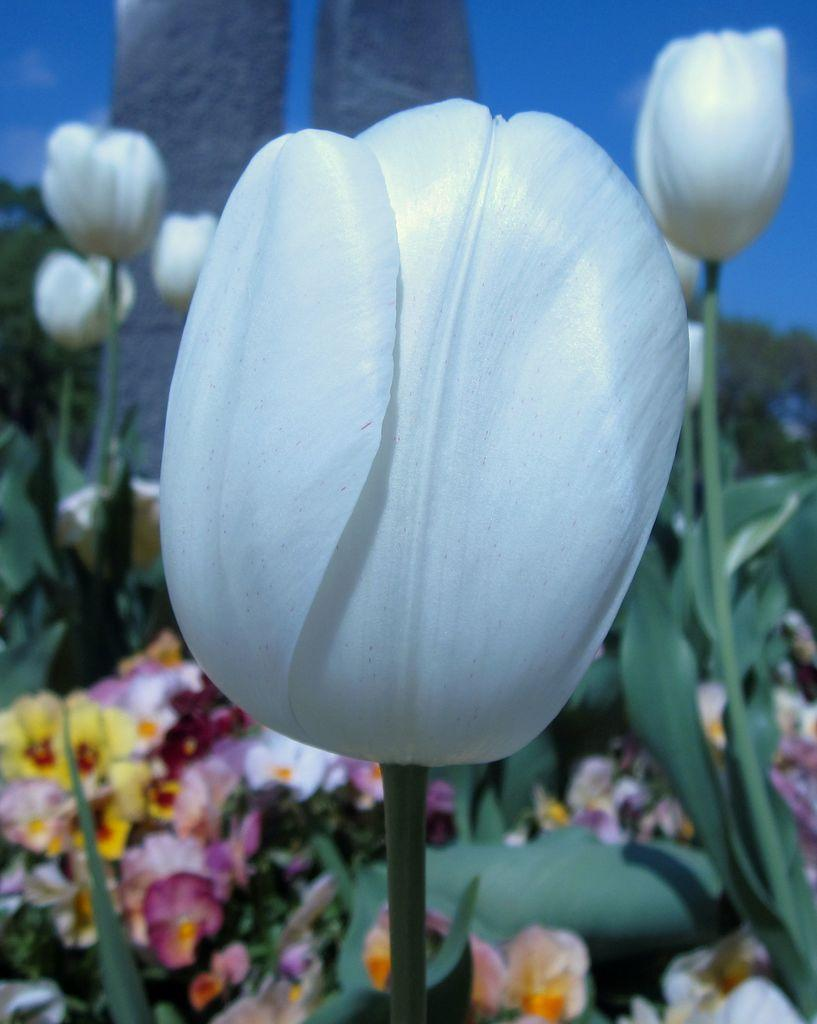What is located in the foreground of the image? There are artificial flowers in the foreground of the image. What are the artificial flowers placed near? The artificial flowers are placed near plants. What can be seen in the background of the image? In the background, there appears to be a painting of sky and greenery on a cardboard. What is the purpose of the airplane in the image? There is no airplane present in the image, so it is not possible to determine its purpose. 